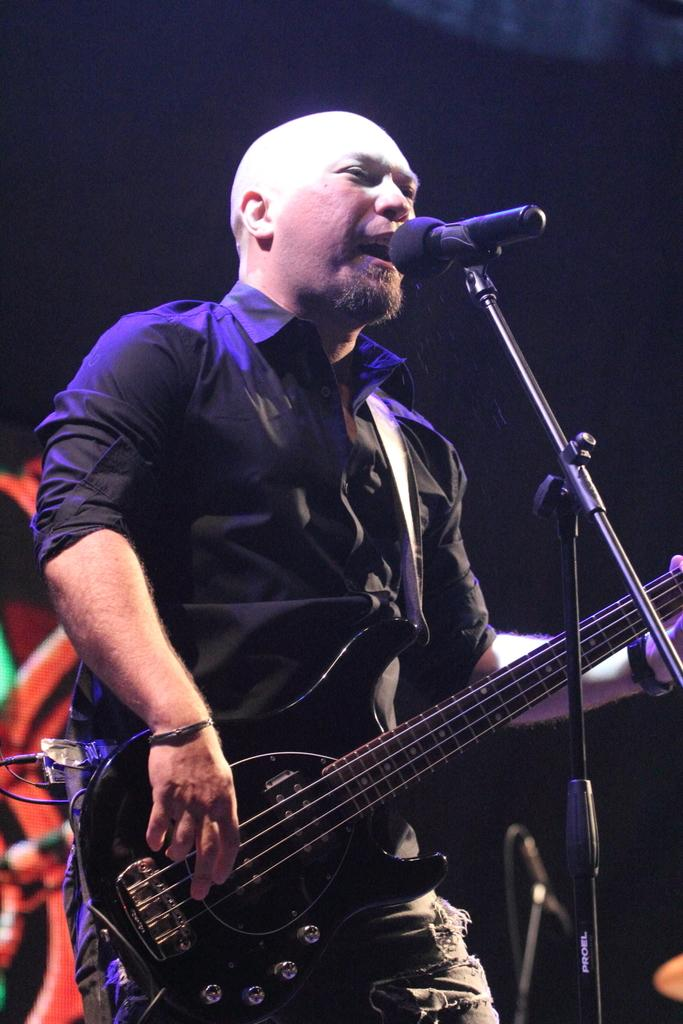What is the man in the image doing? The man is singing and playing the guitar. What object is in front of the man? There is a microphone in front of the man. What is the man wearing? The man is wearing a black shirt and torn jeans. What type of leather is the bee sitting on in the image? There is no bee present in the image, and therefore no leather or bee can be observed. 